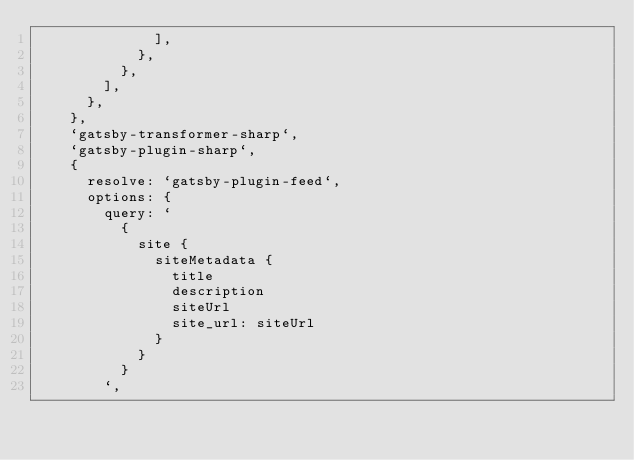Convert code to text. <code><loc_0><loc_0><loc_500><loc_500><_JavaScript_>							],
						},
					},
				],
			},
		},
		`gatsby-transformer-sharp`,
		`gatsby-plugin-sharp`,
		{
			resolve: `gatsby-plugin-feed`,
			options: {
				query: `
					{
						site {
							siteMetadata {
								title
								description
								siteUrl
								site_url: siteUrl
							}
						}
					}
				`,</code> 